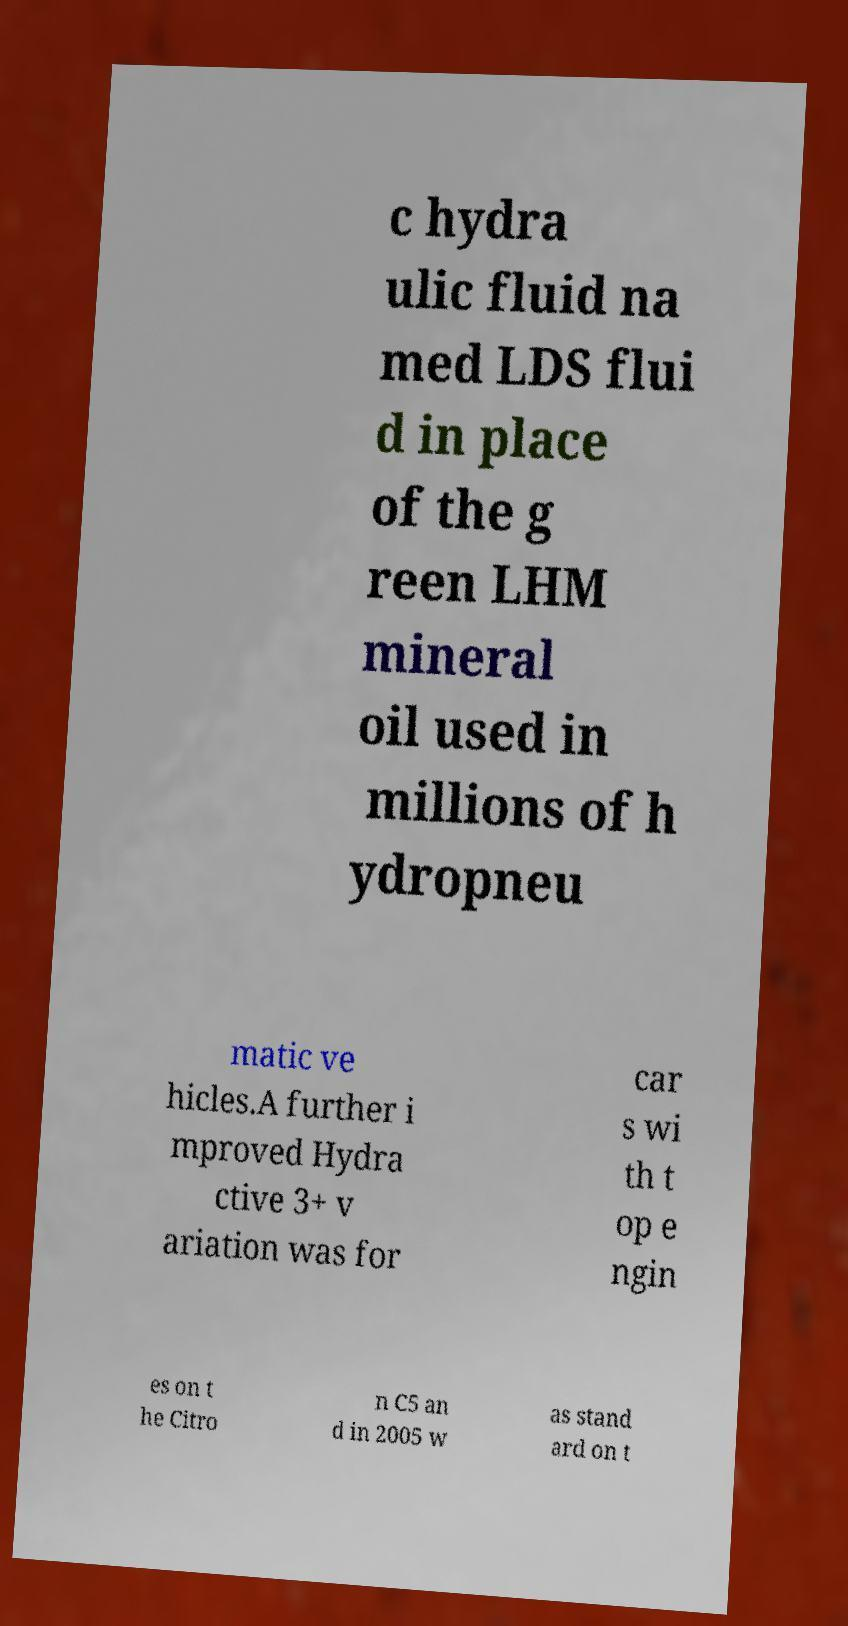Could you assist in decoding the text presented in this image and type it out clearly? c hydra ulic fluid na med LDS flui d in place of the g reen LHM mineral oil used in millions of h ydropneu matic ve hicles.A further i mproved Hydra ctive 3+ v ariation was for car s wi th t op e ngin es on t he Citro n C5 an d in 2005 w as stand ard on t 